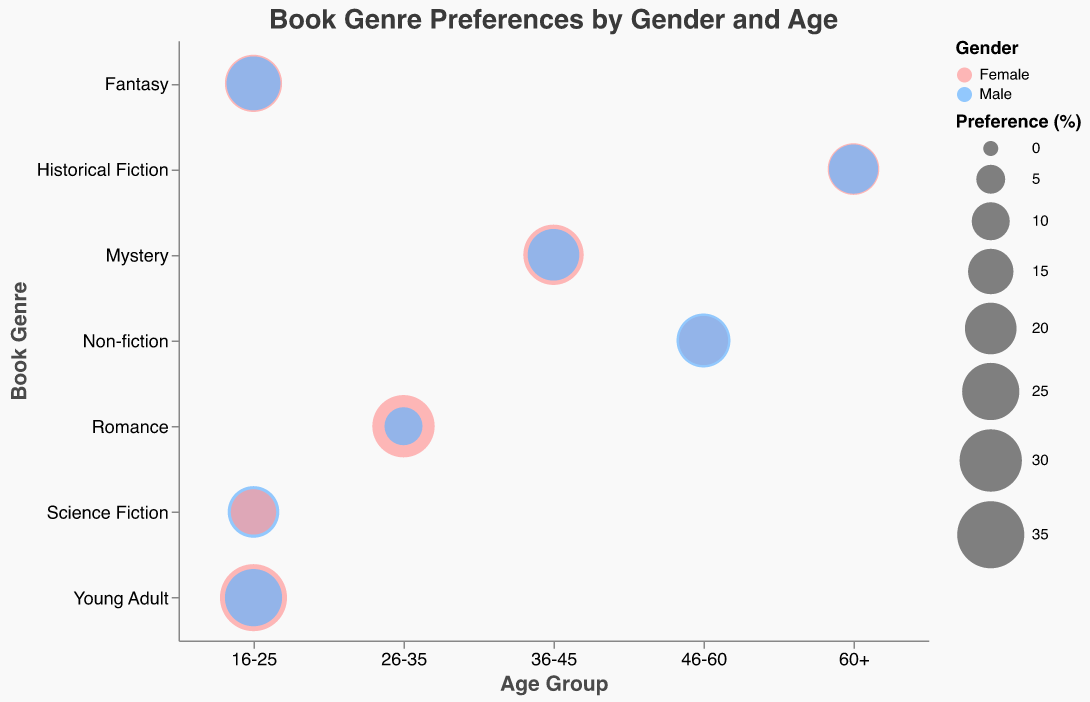What is the title of the figure? The title of the figure is written at the top and reads "Book Genre Preferences by Gender and Age".
Answer: Book Genre Preferences by Gender and Age Which age group shows the highest preference for the "Romance" genre among females? To find the highest preference for the "Romance" genre among females, look at the age groups on the x-axis, and the "Romance" genre on the y-axis. Observe the bubble sizes specific to females. The largest bubble for females in the "Romance" genre is in the 26-35 age group.
Answer: 26-35 What is the percentage difference in preference for "Young Adult" genre between males and females in the 16-25 age group? To determine the percentage difference, look at the "Young Adult" genre in the 16-25 age group and check the data points for males and females. The percentage for females is 35%, and for males, it is 25%. The difference is calculated as 35% - 25%.
Answer: 10% Which gender shows a higher preference for "Non-fiction" in the 46-60 age group? Examine the bubbles for the "Non-fiction" genre in the 46-60 age group on the x-axis. The size of the bubbles indicates the percentage of preferences. For males, the bubble is larger at 22% compared to females at 18%.
Answer: Male What genre shows the highest preference for both genders combined in the 16-25 age group? To find the genre with the highest combined preference in the 16-25 age group, sum the percentages for both genders in each genre. For "Young Adult", females are at 35% and males are at 25%, giving a total of 60%. This is higher than any other genre in this age group.
Answer: Young Adult Compare the preferences for the "Mystery" genre between males and females in the 36-45 age group. Which gender shows a greater preference, and by how much? In the 36-45 age group for the "Mystery" genre, find the preference percentages for both genders. Females have a percentage of 28%, and males have 20%. The difference is calculated as 28% - 20%.
Answer: Female, 8% Is there any genre where both males and females share the same percentage preference? Check all genres across different age groups to find any matching percentages for both genders. No such genre and age group combination exists where males and females share the same percentage.
Answer: No Which book genre has the smallest percentage preference among males aged 26-35? To find the smallest percentage preference for males aged 26-35, look at the genres and their respective bubble sizes. The "Romance" genre has the smallest bubble size for this group at 10%.
Answer: Romance 